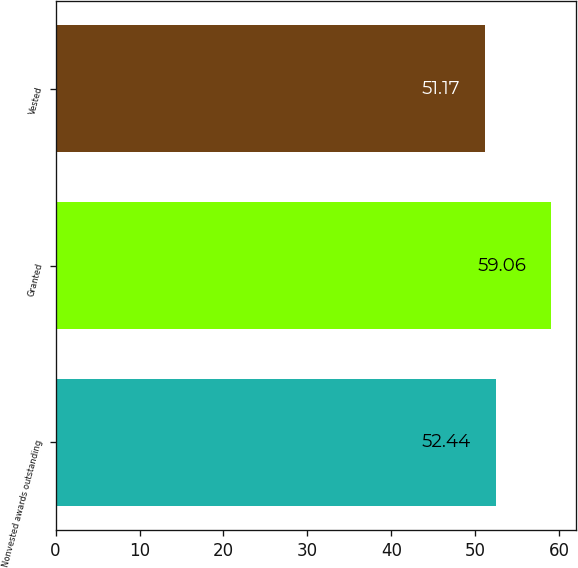Convert chart. <chart><loc_0><loc_0><loc_500><loc_500><bar_chart><fcel>Nonvested awards outstanding<fcel>Granted<fcel>Vested<nl><fcel>52.44<fcel>59.06<fcel>51.17<nl></chart> 